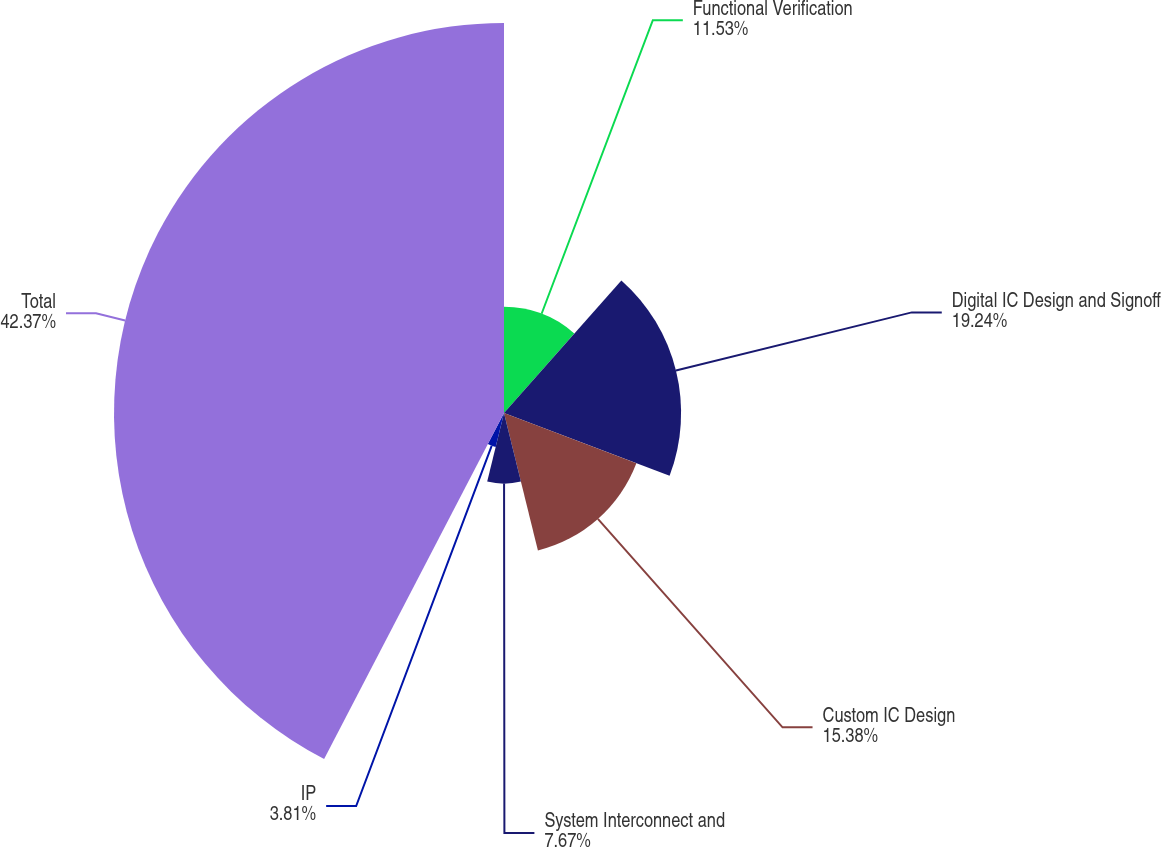Convert chart to OTSL. <chart><loc_0><loc_0><loc_500><loc_500><pie_chart><fcel>Functional Verification<fcel>Digital IC Design and Signoff<fcel>Custom IC Design<fcel>System Interconnect and<fcel>IP<fcel>Total<nl><fcel>11.53%<fcel>19.24%<fcel>15.38%<fcel>7.67%<fcel>3.81%<fcel>42.37%<nl></chart> 